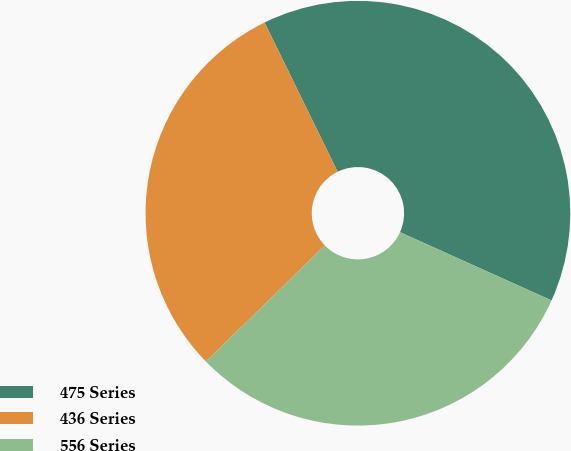Convert chart to OTSL. <chart><loc_0><loc_0><loc_500><loc_500><pie_chart><fcel>475 Series<fcel>436 Series<fcel>556 Series<nl><fcel>38.98%<fcel>30.06%<fcel>30.96%<nl></chart> 